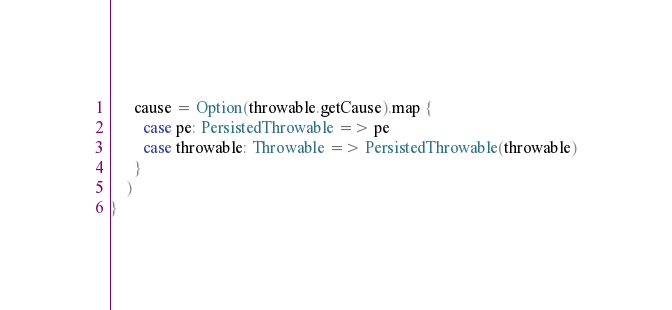Convert code to text. <code><loc_0><loc_0><loc_500><loc_500><_Scala_>      cause = Option(throwable.getCause).map {
        case pe: PersistedThrowable => pe
        case throwable: Throwable => PersistedThrowable(throwable)
      }
    )
}
</code> 